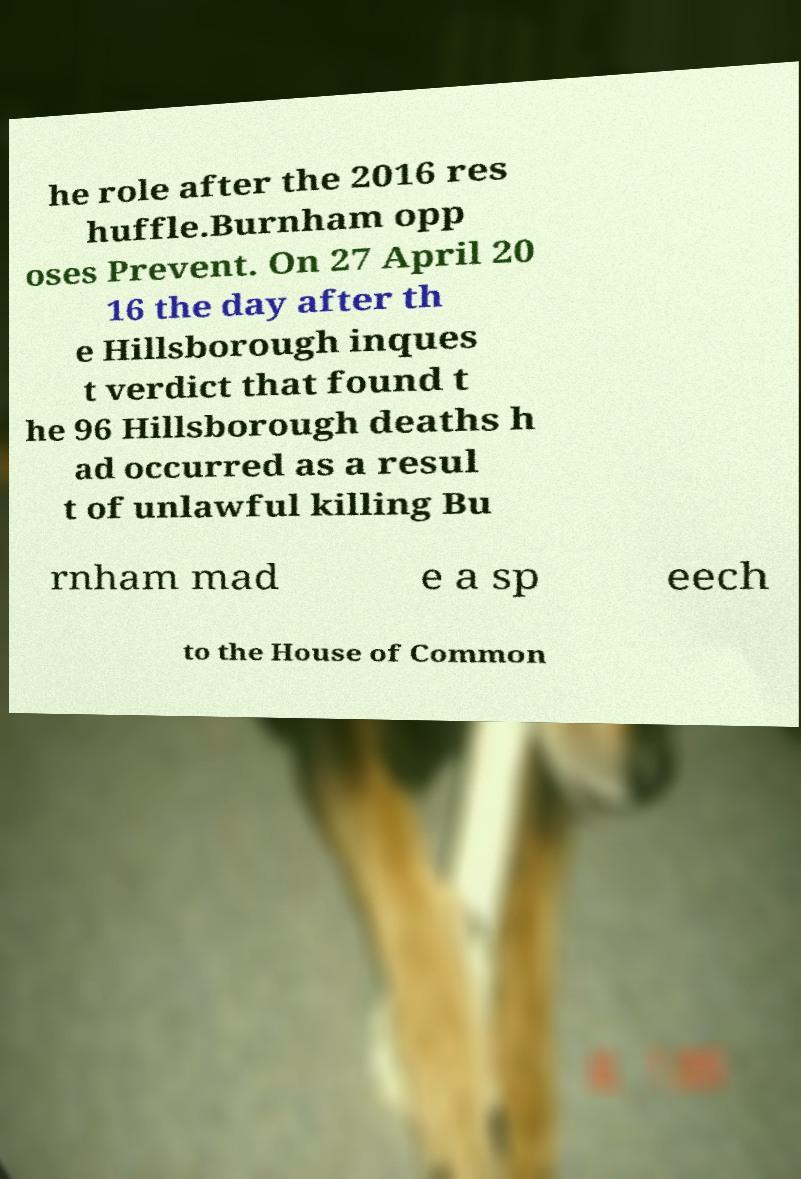What messages or text are displayed in this image? I need them in a readable, typed format. he role after the 2016 res huffle.Burnham opp oses Prevent. On 27 April 20 16 the day after th e Hillsborough inques t verdict that found t he 96 Hillsborough deaths h ad occurred as a resul t of unlawful killing Bu rnham mad e a sp eech to the House of Common 